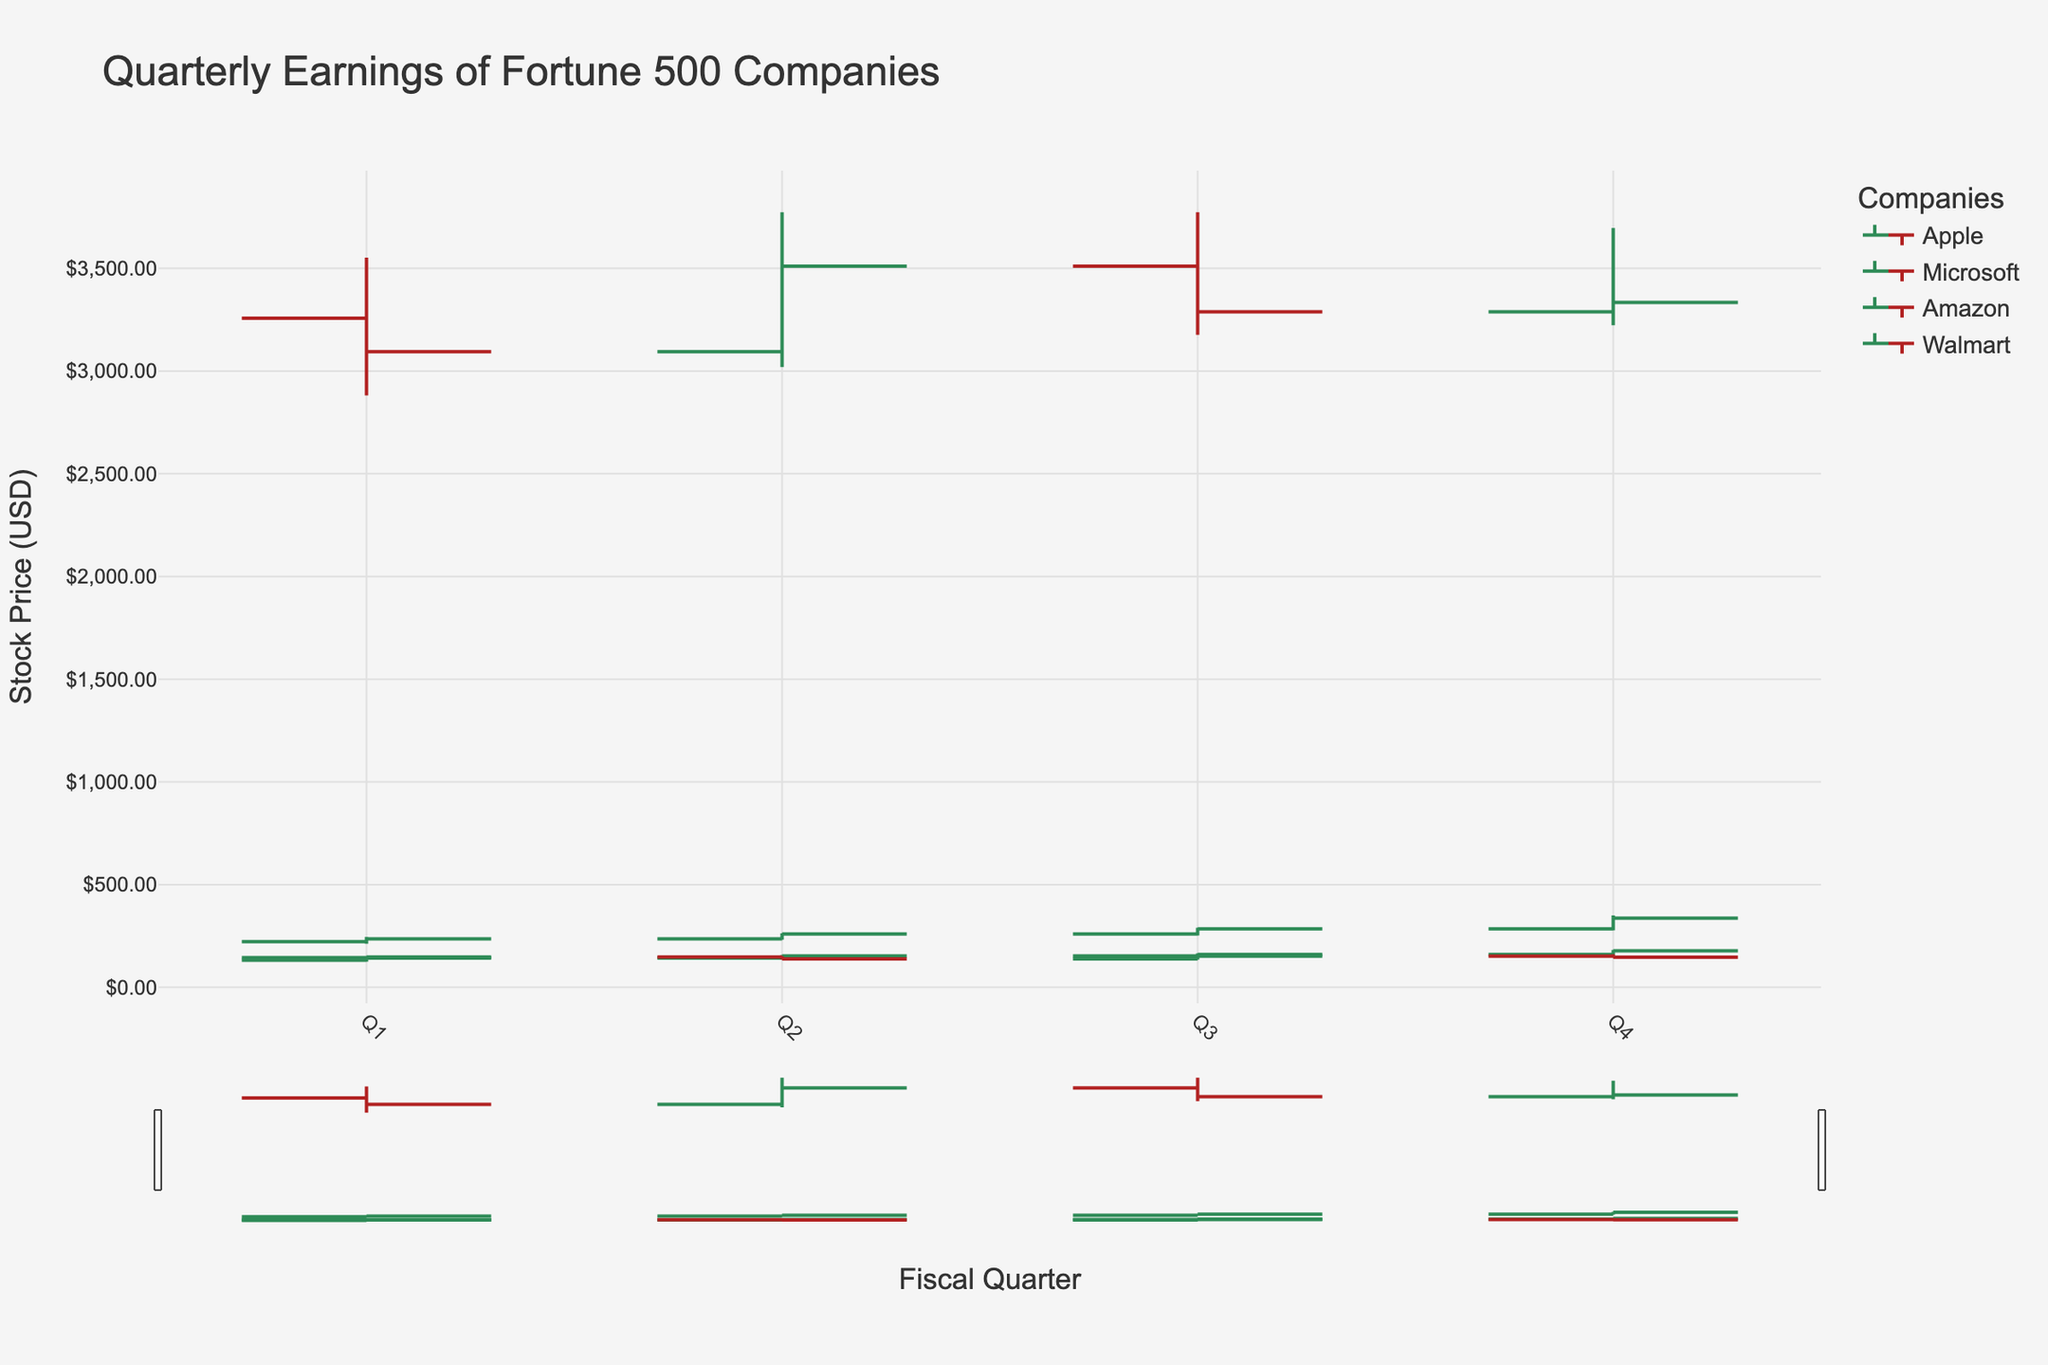What is the title of the chart? The title is always located at the top of the chart. By looking at the chart, we can see the text displayed at the top center.
Answer: Quarterly Earnings of Fortune 500 Companies How many companies are represented in the chart? This can be determined by examining the legend, which lists the unique companies depicted in the chart.
Answer: 4 Which company has the highest closing price in Q4? By inspecting the 'Close' values for Q4 for each company, we see that Amazon has the highest closing price in that quarter.
Answer: Amazon What is the open price for Microsoft in Q2? By finding Microsoft's data for Q2 and checking the corresponding 'Open' value, we can determine the open price.
Answer: 235.77 How does Apple's opening price in Q1 compare to its closing price in Q4? To answer this, check Apple's 'Open' price in Q1 and its 'Close' price in Q4, then compare them. Apple's opening price in Q1 is lower than its closing price in Q4.
Answer: Lower Which company showed the most significant increase from Q3 to Q4? Compare the 'Close' prices from Q3 to Q4 for each company and calculate the differences. Microsoft showed the most significant increase.
Answer: Microsoft What is the average closing price of Walmart across all quarters? By summing the closing prices of Walmart for each quarter and then dividing by the number of quarters (4), we find the average.  (147.45 + 138.75 + 151.47 + 146.91) / 4 = 146.145
Answer: 146.145 During which quarter did Amazon experience its lowest low price? For Amazon, we check the 'Low' values across all quarters and identify the minimum value, which is 2881.00 in Q1.
Answer: Q1 In which quarter did Apple's stock reach its highest high, and what was the value? By examining the 'High' values for Apple in each quarter, we find the maximum value and identify the corresponding quarter. The highest high was 182.13 in Q4.
Answer: Q4, 182.13 What is the difference between the highest high and the lowest low for Microsoft in the last fiscal year? We identify Microsoft's highest 'High' and lowest 'Low' values for the year and subtract the two. 349.67 (highest high) - 212.03 (lowest low) = 137.64
Answer: 137.64 